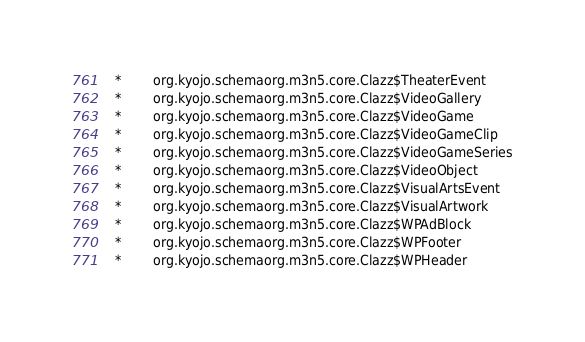Convert code to text. <code><loc_0><loc_0><loc_500><loc_500><_SQL_>  *        org.kyojo.schemaorg.m3n5.core.Clazz$TheaterEvent
  *        org.kyojo.schemaorg.m3n5.core.Clazz$VideoGallery
  *        org.kyojo.schemaorg.m3n5.core.Clazz$VideoGame
  *        org.kyojo.schemaorg.m3n5.core.Clazz$VideoGameClip
  *        org.kyojo.schemaorg.m3n5.core.Clazz$VideoGameSeries
  *        org.kyojo.schemaorg.m3n5.core.Clazz$VideoObject
  *        org.kyojo.schemaorg.m3n5.core.Clazz$VisualArtsEvent
  *        org.kyojo.schemaorg.m3n5.core.Clazz$VisualArtwork
  *        org.kyojo.schemaorg.m3n5.core.Clazz$WPAdBlock
  *        org.kyojo.schemaorg.m3n5.core.Clazz$WPFooter
  *        org.kyojo.schemaorg.m3n5.core.Clazz$WPHeader</code> 